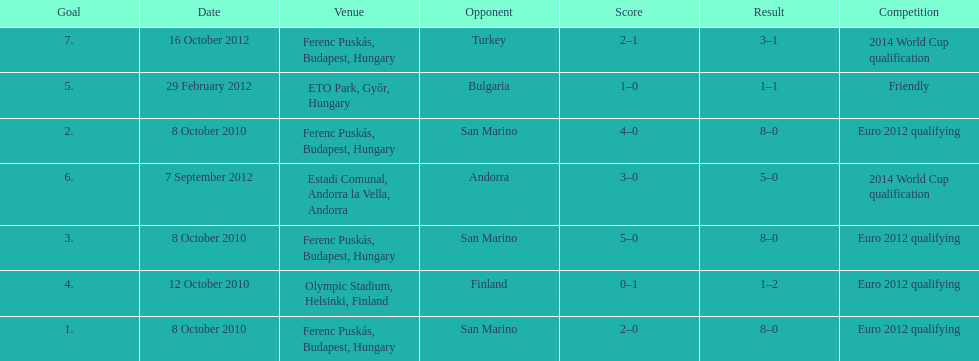Szalai scored all but one of his international goals in either euro 2012 qualifying or what other level of play? 2014 World Cup qualification. 